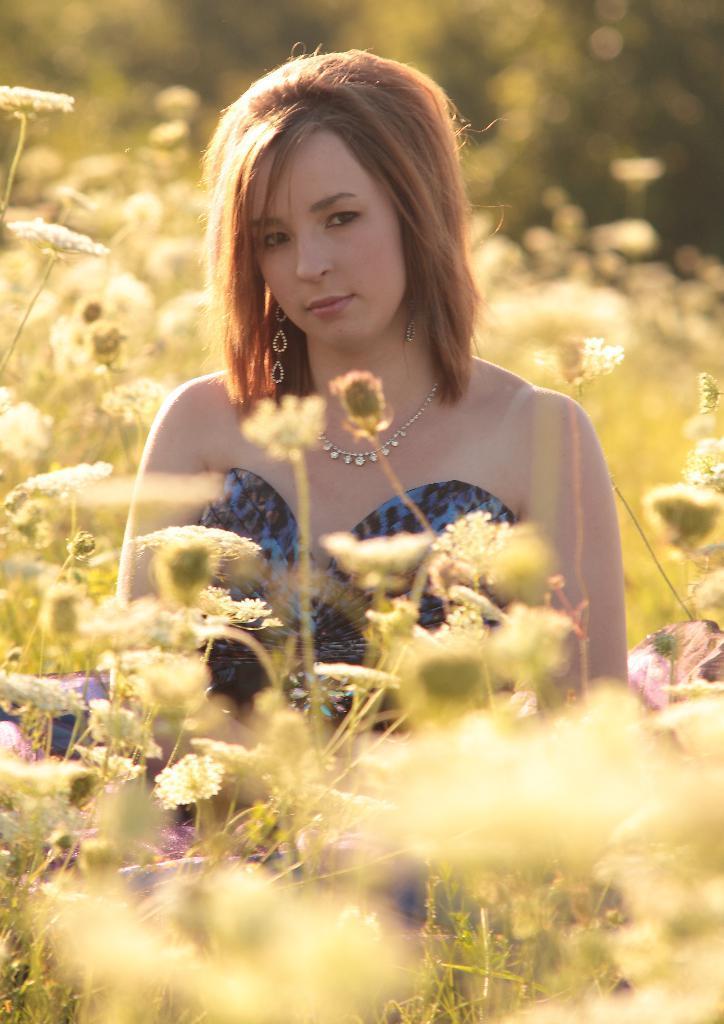Describe this image in one or two sentences. This is a woman wearing dress, these are plants. 